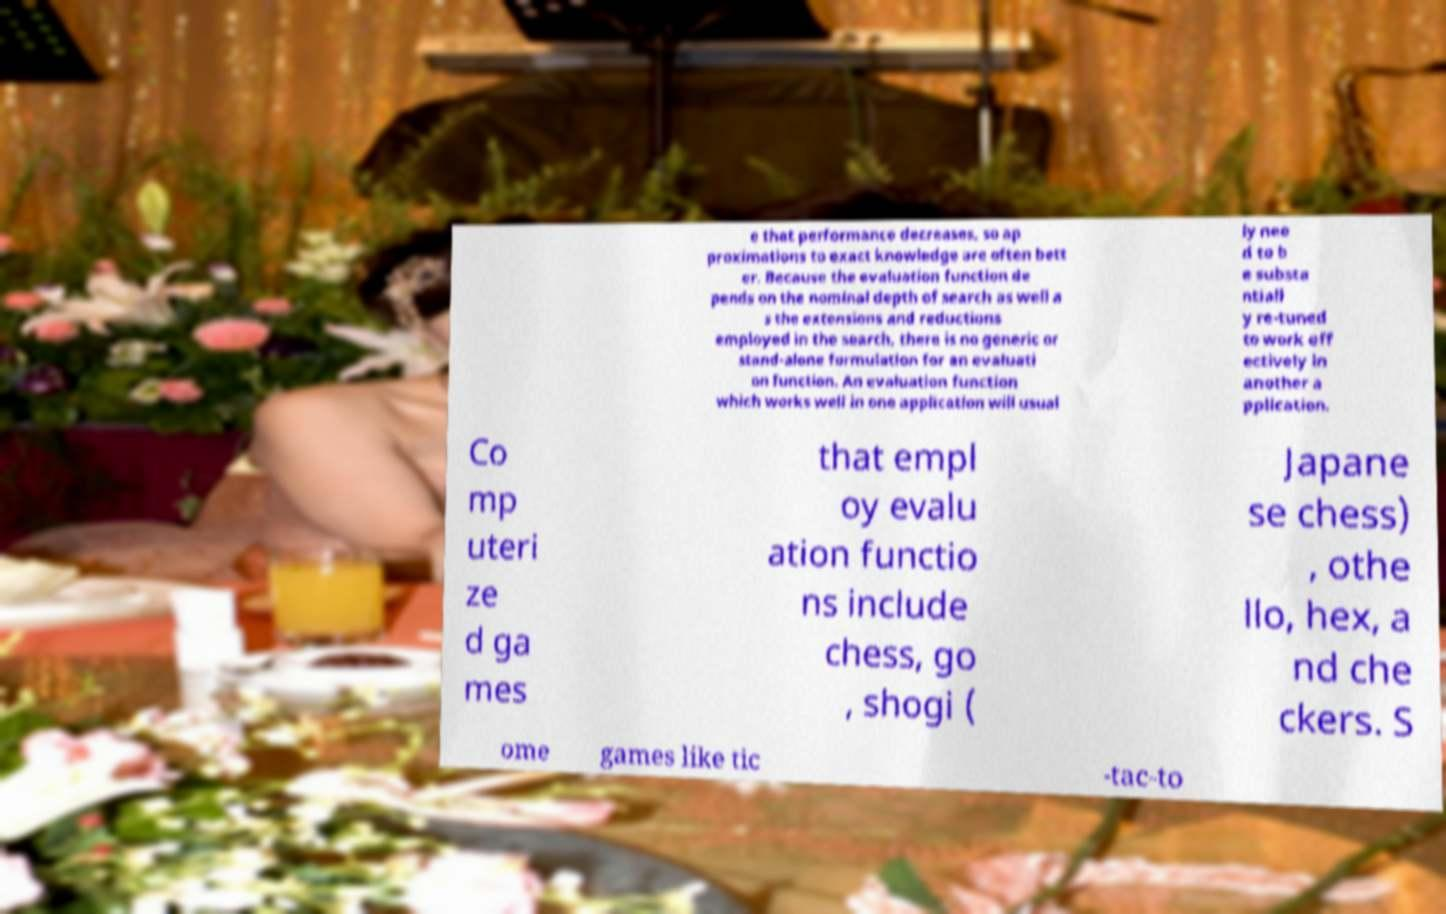Could you extract and type out the text from this image? e that performance decreases, so ap proximations to exact knowledge are often bett er. Because the evaluation function de pends on the nominal depth of search as well a s the extensions and reductions employed in the search, there is no generic or stand-alone formulation for an evaluati on function. An evaluation function which works well in one application will usual ly nee d to b e substa ntiall y re-tuned to work eff ectively in another a pplication. Co mp uteri ze d ga mes that empl oy evalu ation functio ns include chess, go , shogi ( Japane se chess) , othe llo, hex, a nd che ckers. S ome games like tic -tac-to 